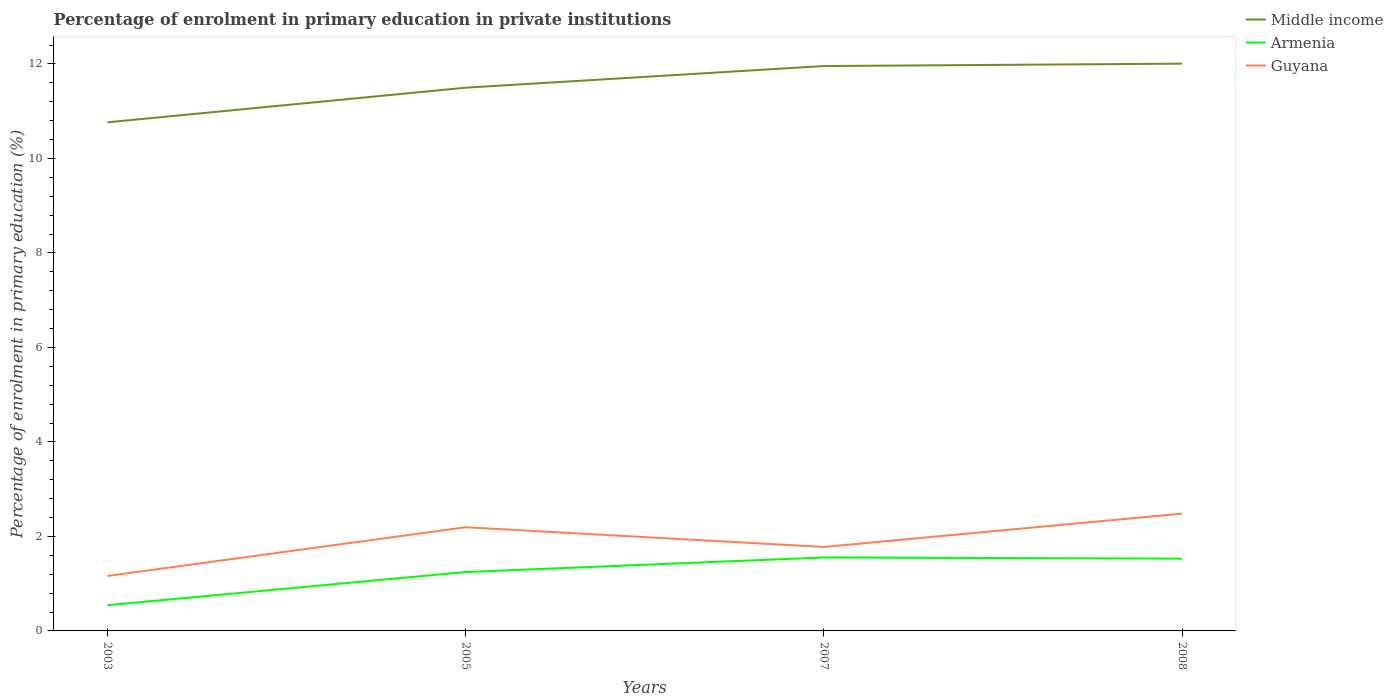How many different coloured lines are there?
Your answer should be very brief. 3. Across all years, what is the maximum percentage of enrolment in primary education in Armenia?
Ensure brevity in your answer.  0.54. What is the total percentage of enrolment in primary education in Armenia in the graph?
Give a very brief answer. 0.02. What is the difference between the highest and the second highest percentage of enrolment in primary education in Armenia?
Offer a very short reply. 1.01. What is the difference between two consecutive major ticks on the Y-axis?
Make the answer very short. 2. Does the graph contain any zero values?
Your answer should be compact. No. Does the graph contain grids?
Keep it short and to the point. No. What is the title of the graph?
Your response must be concise. Percentage of enrolment in primary education in private institutions. Does "Luxembourg" appear as one of the legend labels in the graph?
Give a very brief answer. No. What is the label or title of the Y-axis?
Ensure brevity in your answer.  Percentage of enrolment in primary education (%). What is the Percentage of enrolment in primary education (%) of Middle income in 2003?
Offer a terse response. 10.76. What is the Percentage of enrolment in primary education (%) in Armenia in 2003?
Keep it short and to the point. 0.54. What is the Percentage of enrolment in primary education (%) of Guyana in 2003?
Provide a succinct answer. 1.16. What is the Percentage of enrolment in primary education (%) in Middle income in 2005?
Offer a terse response. 11.5. What is the Percentage of enrolment in primary education (%) of Armenia in 2005?
Your answer should be very brief. 1.25. What is the Percentage of enrolment in primary education (%) in Guyana in 2005?
Offer a very short reply. 2.19. What is the Percentage of enrolment in primary education (%) of Middle income in 2007?
Make the answer very short. 11.96. What is the Percentage of enrolment in primary education (%) in Armenia in 2007?
Your response must be concise. 1.55. What is the Percentage of enrolment in primary education (%) in Guyana in 2007?
Give a very brief answer. 1.78. What is the Percentage of enrolment in primary education (%) in Middle income in 2008?
Your response must be concise. 12.01. What is the Percentage of enrolment in primary education (%) of Armenia in 2008?
Make the answer very short. 1.53. What is the Percentage of enrolment in primary education (%) in Guyana in 2008?
Give a very brief answer. 2.48. Across all years, what is the maximum Percentage of enrolment in primary education (%) in Middle income?
Your answer should be compact. 12.01. Across all years, what is the maximum Percentage of enrolment in primary education (%) in Armenia?
Your response must be concise. 1.55. Across all years, what is the maximum Percentage of enrolment in primary education (%) in Guyana?
Offer a terse response. 2.48. Across all years, what is the minimum Percentage of enrolment in primary education (%) of Middle income?
Ensure brevity in your answer.  10.76. Across all years, what is the minimum Percentage of enrolment in primary education (%) in Armenia?
Ensure brevity in your answer.  0.54. Across all years, what is the minimum Percentage of enrolment in primary education (%) in Guyana?
Offer a terse response. 1.16. What is the total Percentage of enrolment in primary education (%) in Middle income in the graph?
Ensure brevity in your answer.  46.22. What is the total Percentage of enrolment in primary education (%) of Armenia in the graph?
Your response must be concise. 4.88. What is the total Percentage of enrolment in primary education (%) of Guyana in the graph?
Ensure brevity in your answer.  7.62. What is the difference between the Percentage of enrolment in primary education (%) in Middle income in 2003 and that in 2005?
Your response must be concise. -0.73. What is the difference between the Percentage of enrolment in primary education (%) in Armenia in 2003 and that in 2005?
Your answer should be compact. -0.7. What is the difference between the Percentage of enrolment in primary education (%) in Guyana in 2003 and that in 2005?
Provide a succinct answer. -1.03. What is the difference between the Percentage of enrolment in primary education (%) of Middle income in 2003 and that in 2007?
Keep it short and to the point. -1.19. What is the difference between the Percentage of enrolment in primary education (%) of Armenia in 2003 and that in 2007?
Give a very brief answer. -1.01. What is the difference between the Percentage of enrolment in primary education (%) of Guyana in 2003 and that in 2007?
Offer a very short reply. -0.61. What is the difference between the Percentage of enrolment in primary education (%) of Middle income in 2003 and that in 2008?
Your answer should be compact. -1.24. What is the difference between the Percentage of enrolment in primary education (%) of Armenia in 2003 and that in 2008?
Offer a very short reply. -0.99. What is the difference between the Percentage of enrolment in primary education (%) of Guyana in 2003 and that in 2008?
Give a very brief answer. -1.32. What is the difference between the Percentage of enrolment in primary education (%) in Middle income in 2005 and that in 2007?
Make the answer very short. -0.46. What is the difference between the Percentage of enrolment in primary education (%) of Armenia in 2005 and that in 2007?
Your answer should be compact. -0.31. What is the difference between the Percentage of enrolment in primary education (%) in Guyana in 2005 and that in 2007?
Offer a very short reply. 0.42. What is the difference between the Percentage of enrolment in primary education (%) in Middle income in 2005 and that in 2008?
Offer a very short reply. -0.51. What is the difference between the Percentage of enrolment in primary education (%) in Armenia in 2005 and that in 2008?
Your answer should be very brief. -0.28. What is the difference between the Percentage of enrolment in primary education (%) in Guyana in 2005 and that in 2008?
Your answer should be very brief. -0.29. What is the difference between the Percentage of enrolment in primary education (%) in Middle income in 2007 and that in 2008?
Keep it short and to the point. -0.05. What is the difference between the Percentage of enrolment in primary education (%) of Armenia in 2007 and that in 2008?
Ensure brevity in your answer.  0.02. What is the difference between the Percentage of enrolment in primary education (%) of Guyana in 2007 and that in 2008?
Keep it short and to the point. -0.71. What is the difference between the Percentage of enrolment in primary education (%) in Middle income in 2003 and the Percentage of enrolment in primary education (%) in Armenia in 2005?
Your response must be concise. 9.52. What is the difference between the Percentage of enrolment in primary education (%) of Middle income in 2003 and the Percentage of enrolment in primary education (%) of Guyana in 2005?
Give a very brief answer. 8.57. What is the difference between the Percentage of enrolment in primary education (%) in Armenia in 2003 and the Percentage of enrolment in primary education (%) in Guyana in 2005?
Ensure brevity in your answer.  -1.65. What is the difference between the Percentage of enrolment in primary education (%) in Middle income in 2003 and the Percentage of enrolment in primary education (%) in Armenia in 2007?
Your answer should be very brief. 9.21. What is the difference between the Percentage of enrolment in primary education (%) of Middle income in 2003 and the Percentage of enrolment in primary education (%) of Guyana in 2007?
Ensure brevity in your answer.  8.99. What is the difference between the Percentage of enrolment in primary education (%) in Armenia in 2003 and the Percentage of enrolment in primary education (%) in Guyana in 2007?
Keep it short and to the point. -1.23. What is the difference between the Percentage of enrolment in primary education (%) in Middle income in 2003 and the Percentage of enrolment in primary education (%) in Armenia in 2008?
Ensure brevity in your answer.  9.23. What is the difference between the Percentage of enrolment in primary education (%) in Middle income in 2003 and the Percentage of enrolment in primary education (%) in Guyana in 2008?
Offer a very short reply. 8.28. What is the difference between the Percentage of enrolment in primary education (%) of Armenia in 2003 and the Percentage of enrolment in primary education (%) of Guyana in 2008?
Ensure brevity in your answer.  -1.94. What is the difference between the Percentage of enrolment in primary education (%) of Middle income in 2005 and the Percentage of enrolment in primary education (%) of Armenia in 2007?
Your answer should be very brief. 9.94. What is the difference between the Percentage of enrolment in primary education (%) of Middle income in 2005 and the Percentage of enrolment in primary education (%) of Guyana in 2007?
Ensure brevity in your answer.  9.72. What is the difference between the Percentage of enrolment in primary education (%) in Armenia in 2005 and the Percentage of enrolment in primary education (%) in Guyana in 2007?
Provide a short and direct response. -0.53. What is the difference between the Percentage of enrolment in primary education (%) of Middle income in 2005 and the Percentage of enrolment in primary education (%) of Armenia in 2008?
Provide a short and direct response. 9.97. What is the difference between the Percentage of enrolment in primary education (%) of Middle income in 2005 and the Percentage of enrolment in primary education (%) of Guyana in 2008?
Ensure brevity in your answer.  9.01. What is the difference between the Percentage of enrolment in primary education (%) in Armenia in 2005 and the Percentage of enrolment in primary education (%) in Guyana in 2008?
Ensure brevity in your answer.  -1.24. What is the difference between the Percentage of enrolment in primary education (%) of Middle income in 2007 and the Percentage of enrolment in primary education (%) of Armenia in 2008?
Your answer should be compact. 10.43. What is the difference between the Percentage of enrolment in primary education (%) in Middle income in 2007 and the Percentage of enrolment in primary education (%) in Guyana in 2008?
Your answer should be compact. 9.47. What is the difference between the Percentage of enrolment in primary education (%) of Armenia in 2007 and the Percentage of enrolment in primary education (%) of Guyana in 2008?
Offer a terse response. -0.93. What is the average Percentage of enrolment in primary education (%) of Middle income per year?
Your response must be concise. 11.56. What is the average Percentage of enrolment in primary education (%) of Armenia per year?
Your response must be concise. 1.22. What is the average Percentage of enrolment in primary education (%) in Guyana per year?
Your answer should be very brief. 1.9. In the year 2003, what is the difference between the Percentage of enrolment in primary education (%) in Middle income and Percentage of enrolment in primary education (%) in Armenia?
Provide a short and direct response. 10.22. In the year 2003, what is the difference between the Percentage of enrolment in primary education (%) in Middle income and Percentage of enrolment in primary education (%) in Guyana?
Give a very brief answer. 9.6. In the year 2003, what is the difference between the Percentage of enrolment in primary education (%) in Armenia and Percentage of enrolment in primary education (%) in Guyana?
Your answer should be very brief. -0.62. In the year 2005, what is the difference between the Percentage of enrolment in primary education (%) in Middle income and Percentage of enrolment in primary education (%) in Armenia?
Give a very brief answer. 10.25. In the year 2005, what is the difference between the Percentage of enrolment in primary education (%) of Middle income and Percentage of enrolment in primary education (%) of Guyana?
Keep it short and to the point. 9.3. In the year 2005, what is the difference between the Percentage of enrolment in primary education (%) of Armenia and Percentage of enrolment in primary education (%) of Guyana?
Make the answer very short. -0.95. In the year 2007, what is the difference between the Percentage of enrolment in primary education (%) of Middle income and Percentage of enrolment in primary education (%) of Armenia?
Your answer should be compact. 10.4. In the year 2007, what is the difference between the Percentage of enrolment in primary education (%) of Middle income and Percentage of enrolment in primary education (%) of Guyana?
Offer a very short reply. 10.18. In the year 2007, what is the difference between the Percentage of enrolment in primary education (%) of Armenia and Percentage of enrolment in primary education (%) of Guyana?
Offer a very short reply. -0.22. In the year 2008, what is the difference between the Percentage of enrolment in primary education (%) of Middle income and Percentage of enrolment in primary education (%) of Armenia?
Provide a short and direct response. 10.48. In the year 2008, what is the difference between the Percentage of enrolment in primary education (%) of Middle income and Percentage of enrolment in primary education (%) of Guyana?
Your answer should be very brief. 9.52. In the year 2008, what is the difference between the Percentage of enrolment in primary education (%) of Armenia and Percentage of enrolment in primary education (%) of Guyana?
Offer a terse response. -0.95. What is the ratio of the Percentage of enrolment in primary education (%) in Middle income in 2003 to that in 2005?
Your answer should be compact. 0.94. What is the ratio of the Percentage of enrolment in primary education (%) of Armenia in 2003 to that in 2005?
Offer a terse response. 0.44. What is the ratio of the Percentage of enrolment in primary education (%) in Guyana in 2003 to that in 2005?
Offer a very short reply. 0.53. What is the ratio of the Percentage of enrolment in primary education (%) of Middle income in 2003 to that in 2007?
Provide a succinct answer. 0.9. What is the ratio of the Percentage of enrolment in primary education (%) of Armenia in 2003 to that in 2007?
Provide a succinct answer. 0.35. What is the ratio of the Percentage of enrolment in primary education (%) of Guyana in 2003 to that in 2007?
Offer a terse response. 0.65. What is the ratio of the Percentage of enrolment in primary education (%) of Middle income in 2003 to that in 2008?
Keep it short and to the point. 0.9. What is the ratio of the Percentage of enrolment in primary education (%) in Armenia in 2003 to that in 2008?
Give a very brief answer. 0.36. What is the ratio of the Percentage of enrolment in primary education (%) of Guyana in 2003 to that in 2008?
Provide a short and direct response. 0.47. What is the ratio of the Percentage of enrolment in primary education (%) in Middle income in 2005 to that in 2007?
Ensure brevity in your answer.  0.96. What is the ratio of the Percentage of enrolment in primary education (%) of Armenia in 2005 to that in 2007?
Give a very brief answer. 0.8. What is the ratio of the Percentage of enrolment in primary education (%) of Guyana in 2005 to that in 2007?
Offer a terse response. 1.24. What is the ratio of the Percentage of enrolment in primary education (%) of Middle income in 2005 to that in 2008?
Keep it short and to the point. 0.96. What is the ratio of the Percentage of enrolment in primary education (%) of Armenia in 2005 to that in 2008?
Ensure brevity in your answer.  0.81. What is the ratio of the Percentage of enrolment in primary education (%) of Guyana in 2005 to that in 2008?
Provide a succinct answer. 0.88. What is the ratio of the Percentage of enrolment in primary education (%) of Middle income in 2007 to that in 2008?
Provide a succinct answer. 1. What is the ratio of the Percentage of enrolment in primary education (%) in Armenia in 2007 to that in 2008?
Your answer should be compact. 1.02. What is the ratio of the Percentage of enrolment in primary education (%) of Guyana in 2007 to that in 2008?
Ensure brevity in your answer.  0.72. What is the difference between the highest and the second highest Percentage of enrolment in primary education (%) in Middle income?
Keep it short and to the point. 0.05. What is the difference between the highest and the second highest Percentage of enrolment in primary education (%) in Armenia?
Your response must be concise. 0.02. What is the difference between the highest and the second highest Percentage of enrolment in primary education (%) in Guyana?
Keep it short and to the point. 0.29. What is the difference between the highest and the lowest Percentage of enrolment in primary education (%) of Middle income?
Ensure brevity in your answer.  1.24. What is the difference between the highest and the lowest Percentage of enrolment in primary education (%) of Armenia?
Give a very brief answer. 1.01. What is the difference between the highest and the lowest Percentage of enrolment in primary education (%) of Guyana?
Give a very brief answer. 1.32. 